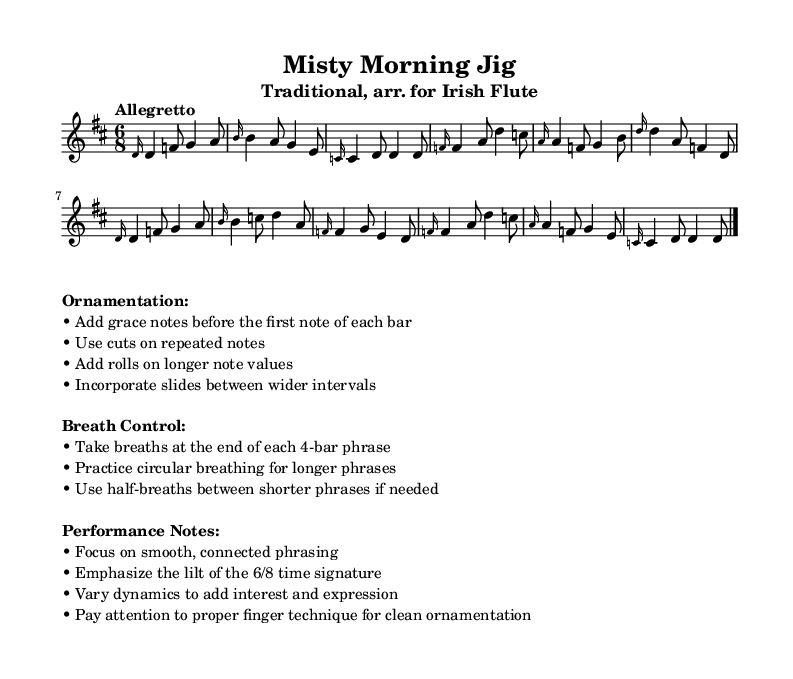What is the key signature of this music? The key signature is D major, which has two sharps: F# and C#. This can be identified by the key signature notation at the beginning of the staff.
Answer: D major What is the time signature of "Misty Morning Jig"? The time signature is 6/8, indicated in the notation following the key signature. This shows that there are six eighth notes per measure.
Answer: 6/8 What is the tempo marking of this piece? The tempo marking is "Allegretto", which suggests a moderately fast speed. It is found above the staff indicating how quickly the piece should be played.
Answer: Allegretto How many bars are in the music? The music consists of 16 bars, counted from the beginning to the end of the score, separating each measure with vertical bar lines.
Answer: 16 What type of ornamentation is suggested for the repeated notes? The music suggests using cuts on repeated notes. This ornamentation style is indicated in the performance notes section.
Answer: Cuts What breathing technique is advised at the end of phrases? It is advised to take breaths at the end of each 4-bar phrase, as stated in the breath control section of the markup.
Answer: Breaths What is a specific performance note regarding phrasing? The performance note advises focusing on smooth, connected phrasing, which helps in achieving a more lyrical interpretation of the piece.
Answer: Smooth, connected phrasing 